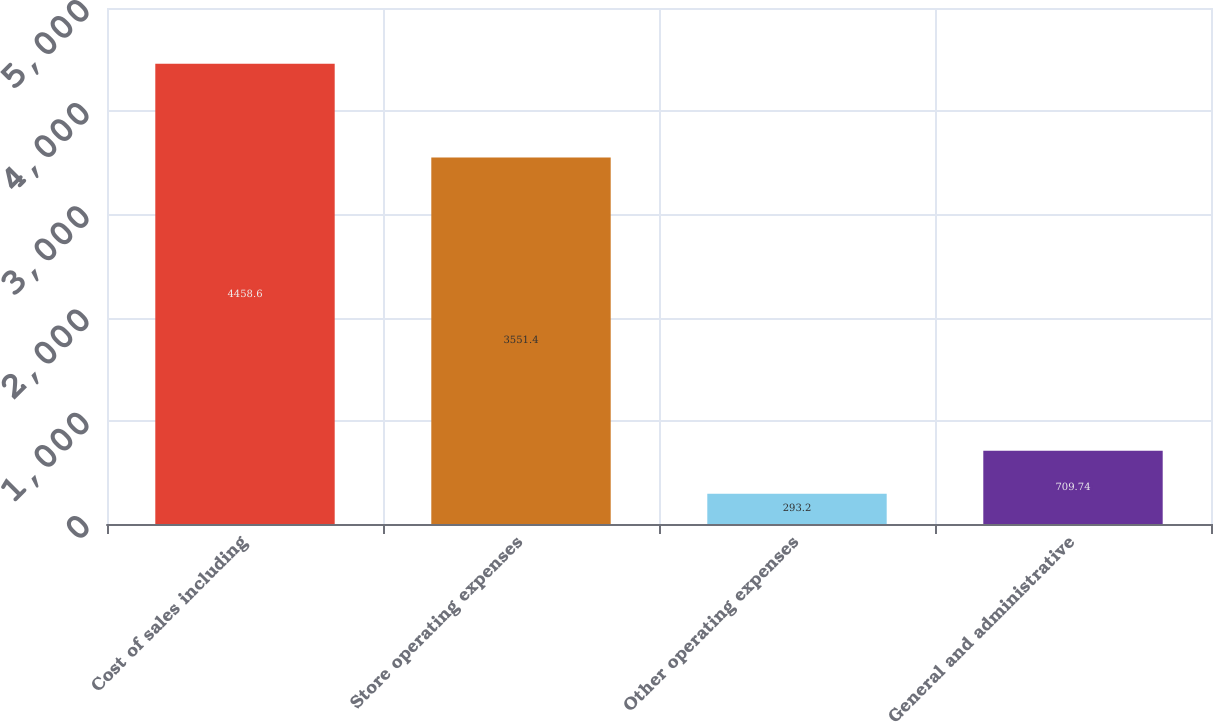Convert chart to OTSL. <chart><loc_0><loc_0><loc_500><loc_500><bar_chart><fcel>Cost of sales including<fcel>Store operating expenses<fcel>Other operating expenses<fcel>General and administrative<nl><fcel>4458.6<fcel>3551.4<fcel>293.2<fcel>709.74<nl></chart> 